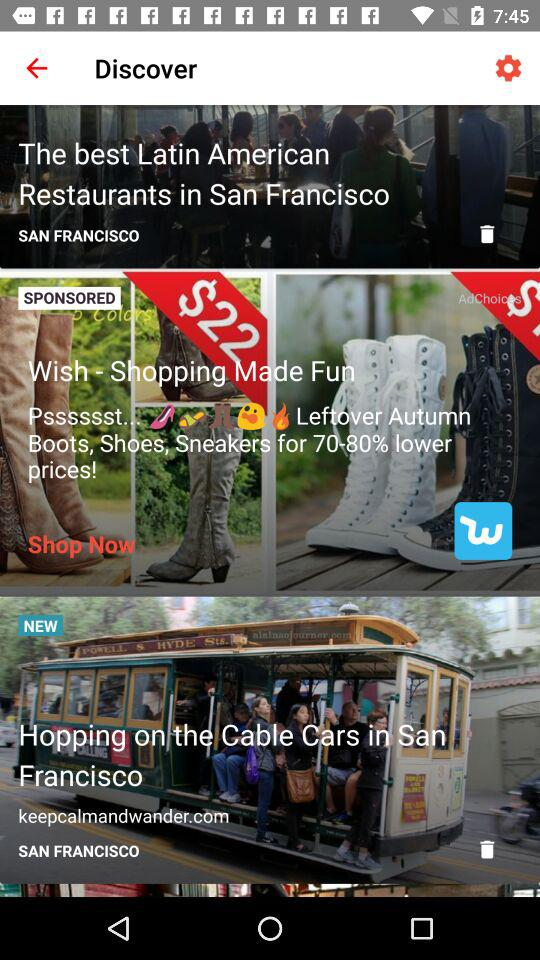How many items are sponsored?
Answer the question using a single word or phrase. 1 